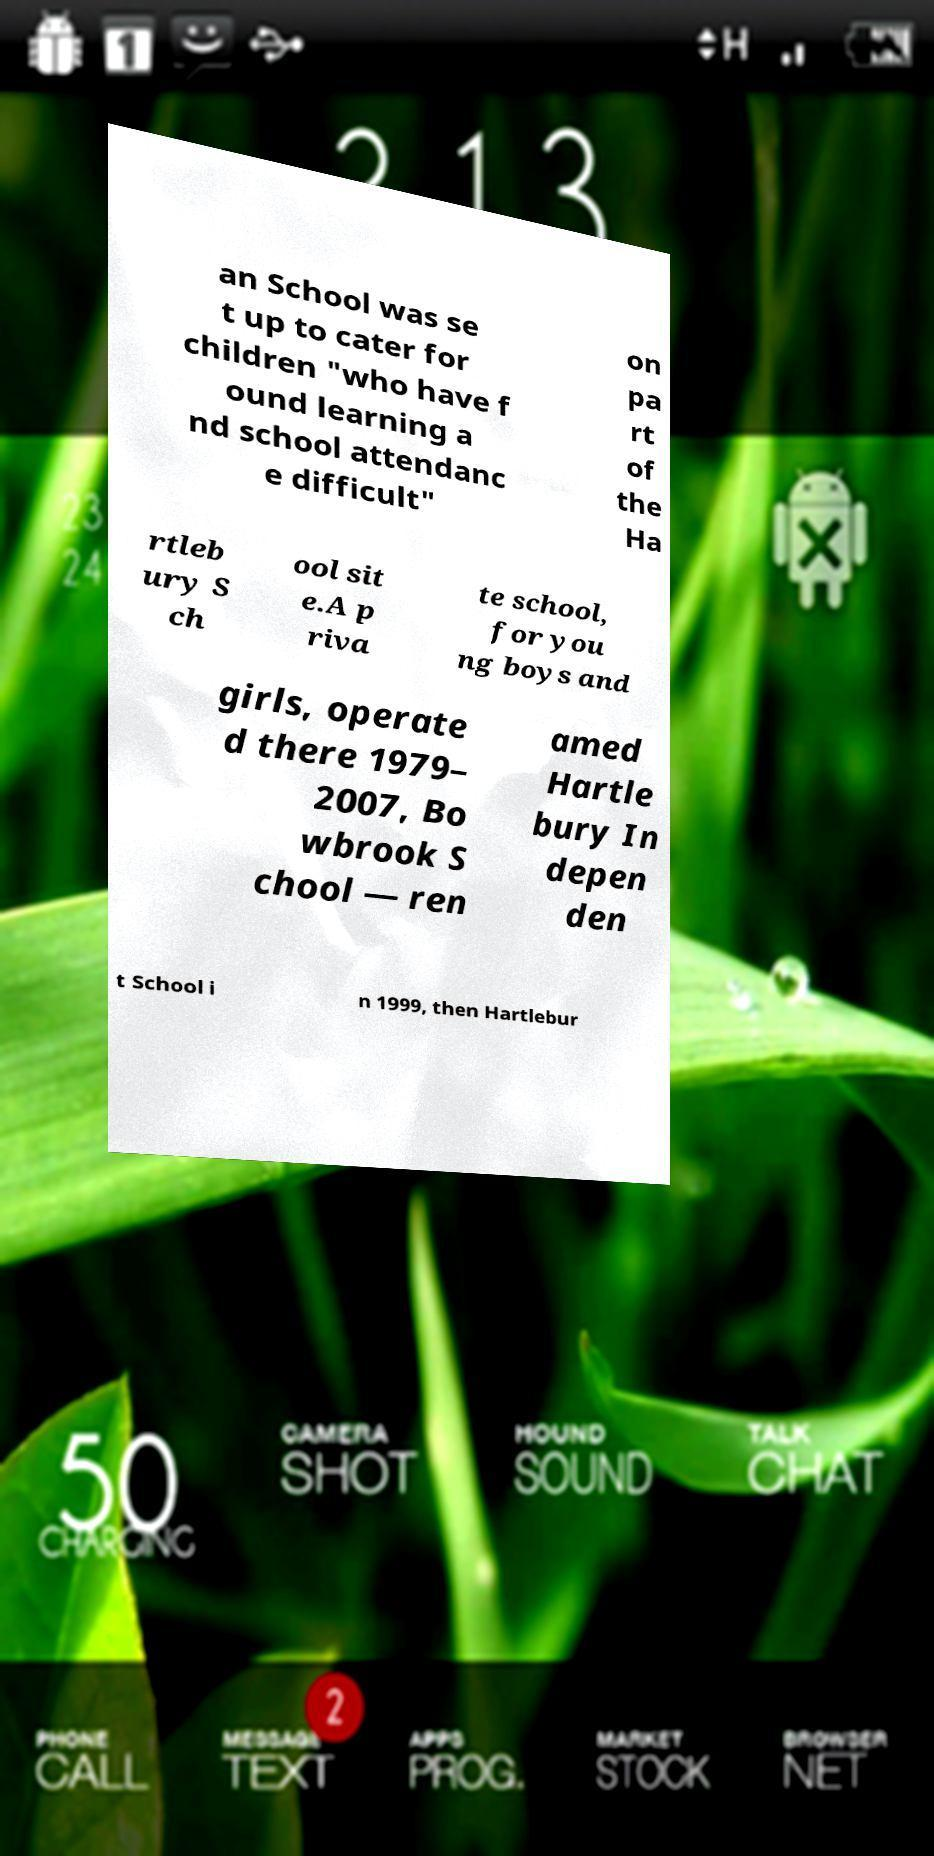There's text embedded in this image that I need extracted. Can you transcribe it verbatim? an School was se t up to cater for children "who have f ound learning a nd school attendanc e difficult" on pa rt of the Ha rtleb ury S ch ool sit e.A p riva te school, for you ng boys and girls, operate d there 1979– 2007, Bo wbrook S chool — ren amed Hartle bury In depen den t School i n 1999, then Hartlebur 